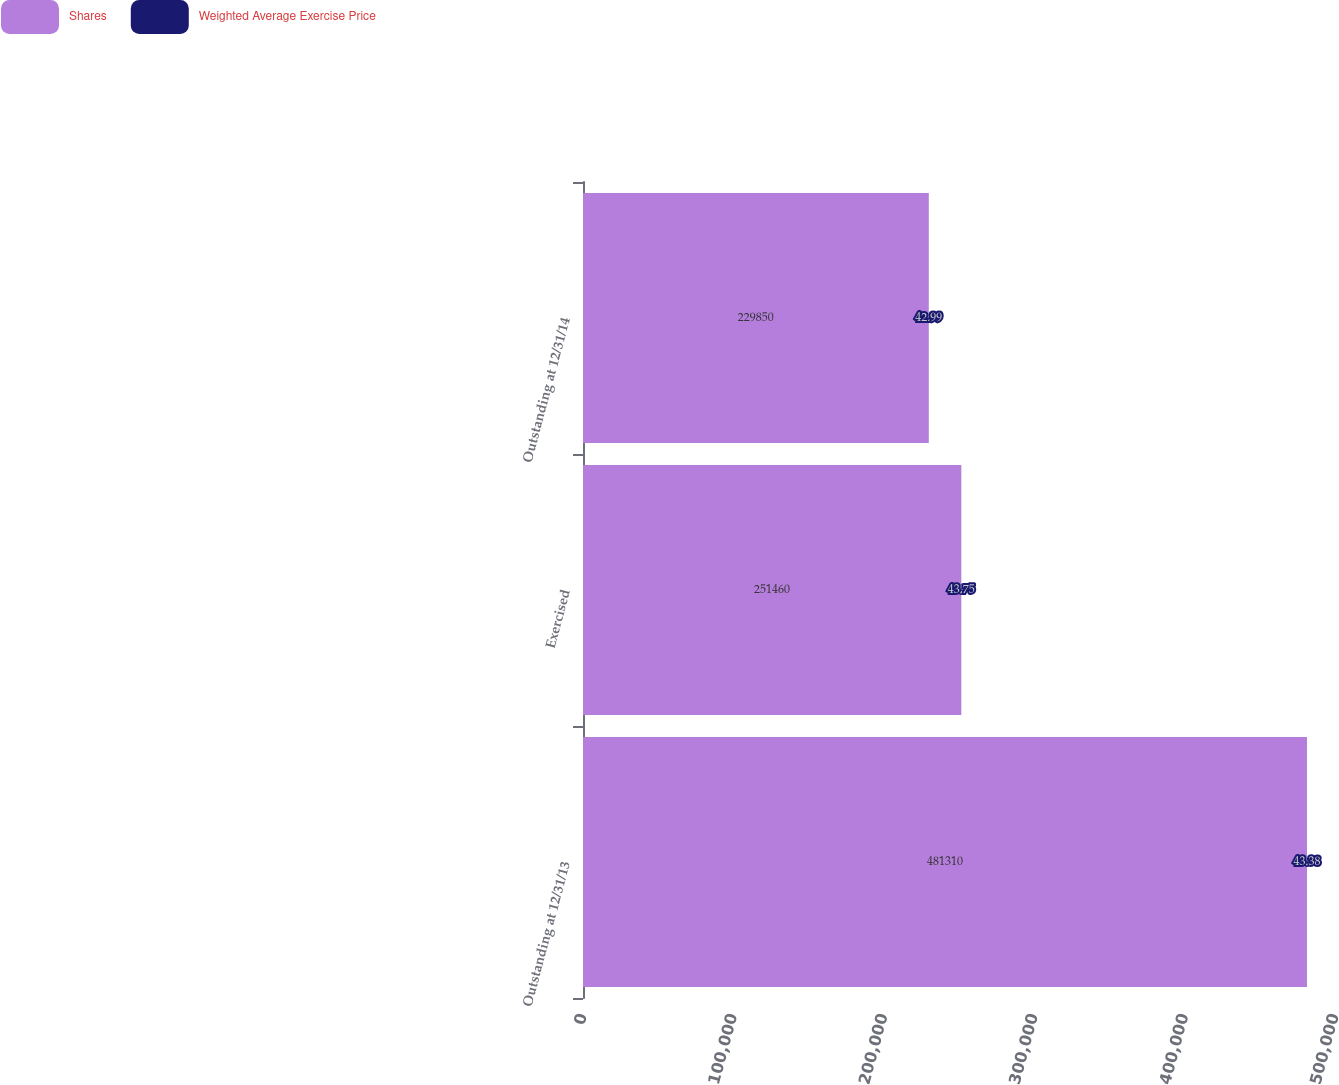<chart> <loc_0><loc_0><loc_500><loc_500><stacked_bar_chart><ecel><fcel>Outstanding at 12/31/13<fcel>Exercised<fcel>Outstanding at 12/31/14<nl><fcel>Shares<fcel>481310<fcel>251460<fcel>229850<nl><fcel>Weighted Average Exercise Price<fcel>43.38<fcel>43.75<fcel>42.99<nl></chart> 